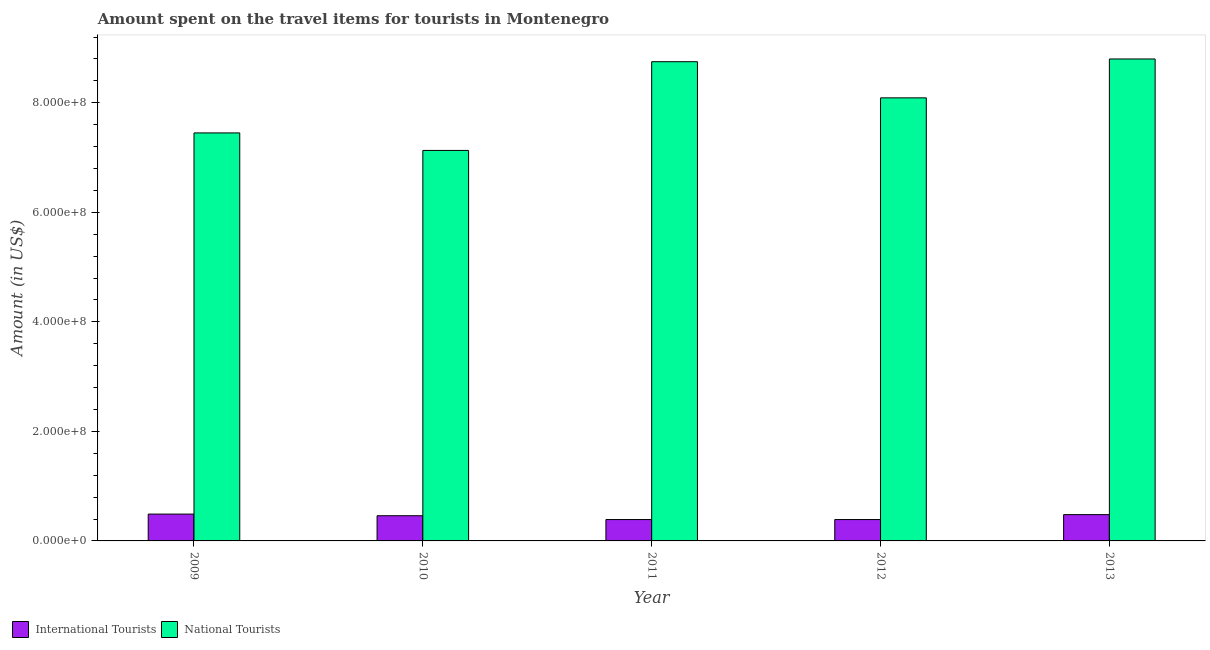How many different coloured bars are there?
Your answer should be very brief. 2. How many groups of bars are there?
Give a very brief answer. 5. How many bars are there on the 5th tick from the right?
Keep it short and to the point. 2. In how many cases, is the number of bars for a given year not equal to the number of legend labels?
Ensure brevity in your answer.  0. What is the amount spent on travel items of national tourists in 2009?
Give a very brief answer. 7.45e+08. Across all years, what is the maximum amount spent on travel items of international tourists?
Provide a succinct answer. 4.90e+07. Across all years, what is the minimum amount spent on travel items of national tourists?
Ensure brevity in your answer.  7.13e+08. In which year was the amount spent on travel items of national tourists maximum?
Give a very brief answer. 2013. In which year was the amount spent on travel items of international tourists minimum?
Your response must be concise. 2011. What is the total amount spent on travel items of national tourists in the graph?
Your answer should be compact. 4.02e+09. What is the difference between the amount spent on travel items of international tourists in 2011 and that in 2013?
Offer a terse response. -9.00e+06. What is the difference between the amount spent on travel items of national tourists in 2013 and the amount spent on travel items of international tourists in 2012?
Offer a very short reply. 7.10e+07. What is the average amount spent on travel items of international tourists per year?
Offer a very short reply. 4.42e+07. In the year 2013, what is the difference between the amount spent on travel items of international tourists and amount spent on travel items of national tourists?
Your answer should be compact. 0. What is the ratio of the amount spent on travel items of national tourists in 2009 to that in 2011?
Your answer should be very brief. 0.85. What is the difference between the highest and the second highest amount spent on travel items of national tourists?
Give a very brief answer. 5.00e+06. What is the difference between the highest and the lowest amount spent on travel items of national tourists?
Ensure brevity in your answer.  1.67e+08. In how many years, is the amount spent on travel items of international tourists greater than the average amount spent on travel items of international tourists taken over all years?
Your answer should be very brief. 3. Is the sum of the amount spent on travel items of national tourists in 2011 and 2012 greater than the maximum amount spent on travel items of international tourists across all years?
Your answer should be very brief. Yes. What does the 2nd bar from the left in 2012 represents?
Make the answer very short. National Tourists. What does the 2nd bar from the right in 2009 represents?
Ensure brevity in your answer.  International Tourists. How many bars are there?
Offer a terse response. 10. Are the values on the major ticks of Y-axis written in scientific E-notation?
Offer a very short reply. Yes. How many legend labels are there?
Provide a short and direct response. 2. How are the legend labels stacked?
Provide a succinct answer. Horizontal. What is the title of the graph?
Provide a succinct answer. Amount spent on the travel items for tourists in Montenegro. Does "RDB nonconcessional" appear as one of the legend labels in the graph?
Keep it short and to the point. No. What is the label or title of the Y-axis?
Your response must be concise. Amount (in US$). What is the Amount (in US$) in International Tourists in 2009?
Offer a very short reply. 4.90e+07. What is the Amount (in US$) in National Tourists in 2009?
Keep it short and to the point. 7.45e+08. What is the Amount (in US$) of International Tourists in 2010?
Offer a very short reply. 4.60e+07. What is the Amount (in US$) of National Tourists in 2010?
Keep it short and to the point. 7.13e+08. What is the Amount (in US$) in International Tourists in 2011?
Your response must be concise. 3.90e+07. What is the Amount (in US$) of National Tourists in 2011?
Provide a short and direct response. 8.75e+08. What is the Amount (in US$) in International Tourists in 2012?
Keep it short and to the point. 3.90e+07. What is the Amount (in US$) of National Tourists in 2012?
Your answer should be very brief. 8.09e+08. What is the Amount (in US$) of International Tourists in 2013?
Make the answer very short. 4.80e+07. What is the Amount (in US$) of National Tourists in 2013?
Offer a terse response. 8.80e+08. Across all years, what is the maximum Amount (in US$) in International Tourists?
Your answer should be compact. 4.90e+07. Across all years, what is the maximum Amount (in US$) in National Tourists?
Your answer should be compact. 8.80e+08. Across all years, what is the minimum Amount (in US$) in International Tourists?
Offer a terse response. 3.90e+07. Across all years, what is the minimum Amount (in US$) in National Tourists?
Make the answer very short. 7.13e+08. What is the total Amount (in US$) in International Tourists in the graph?
Offer a terse response. 2.21e+08. What is the total Amount (in US$) in National Tourists in the graph?
Make the answer very short. 4.02e+09. What is the difference between the Amount (in US$) of International Tourists in 2009 and that in 2010?
Your answer should be compact. 3.00e+06. What is the difference between the Amount (in US$) of National Tourists in 2009 and that in 2010?
Make the answer very short. 3.20e+07. What is the difference between the Amount (in US$) of National Tourists in 2009 and that in 2011?
Make the answer very short. -1.30e+08. What is the difference between the Amount (in US$) of National Tourists in 2009 and that in 2012?
Offer a terse response. -6.40e+07. What is the difference between the Amount (in US$) of International Tourists in 2009 and that in 2013?
Provide a short and direct response. 1.00e+06. What is the difference between the Amount (in US$) in National Tourists in 2009 and that in 2013?
Offer a very short reply. -1.35e+08. What is the difference between the Amount (in US$) of National Tourists in 2010 and that in 2011?
Give a very brief answer. -1.62e+08. What is the difference between the Amount (in US$) in National Tourists in 2010 and that in 2012?
Make the answer very short. -9.60e+07. What is the difference between the Amount (in US$) in National Tourists in 2010 and that in 2013?
Give a very brief answer. -1.67e+08. What is the difference between the Amount (in US$) in National Tourists in 2011 and that in 2012?
Keep it short and to the point. 6.60e+07. What is the difference between the Amount (in US$) of International Tourists in 2011 and that in 2013?
Your answer should be compact. -9.00e+06. What is the difference between the Amount (in US$) in National Tourists in 2011 and that in 2013?
Offer a terse response. -5.00e+06. What is the difference between the Amount (in US$) of International Tourists in 2012 and that in 2013?
Your answer should be very brief. -9.00e+06. What is the difference between the Amount (in US$) of National Tourists in 2012 and that in 2013?
Your answer should be compact. -7.10e+07. What is the difference between the Amount (in US$) of International Tourists in 2009 and the Amount (in US$) of National Tourists in 2010?
Give a very brief answer. -6.64e+08. What is the difference between the Amount (in US$) in International Tourists in 2009 and the Amount (in US$) in National Tourists in 2011?
Provide a succinct answer. -8.26e+08. What is the difference between the Amount (in US$) of International Tourists in 2009 and the Amount (in US$) of National Tourists in 2012?
Your answer should be compact. -7.60e+08. What is the difference between the Amount (in US$) in International Tourists in 2009 and the Amount (in US$) in National Tourists in 2013?
Give a very brief answer. -8.31e+08. What is the difference between the Amount (in US$) of International Tourists in 2010 and the Amount (in US$) of National Tourists in 2011?
Your answer should be very brief. -8.29e+08. What is the difference between the Amount (in US$) of International Tourists in 2010 and the Amount (in US$) of National Tourists in 2012?
Offer a very short reply. -7.63e+08. What is the difference between the Amount (in US$) of International Tourists in 2010 and the Amount (in US$) of National Tourists in 2013?
Ensure brevity in your answer.  -8.34e+08. What is the difference between the Amount (in US$) of International Tourists in 2011 and the Amount (in US$) of National Tourists in 2012?
Make the answer very short. -7.70e+08. What is the difference between the Amount (in US$) of International Tourists in 2011 and the Amount (in US$) of National Tourists in 2013?
Make the answer very short. -8.41e+08. What is the difference between the Amount (in US$) of International Tourists in 2012 and the Amount (in US$) of National Tourists in 2013?
Offer a terse response. -8.41e+08. What is the average Amount (in US$) in International Tourists per year?
Ensure brevity in your answer.  4.42e+07. What is the average Amount (in US$) of National Tourists per year?
Make the answer very short. 8.04e+08. In the year 2009, what is the difference between the Amount (in US$) in International Tourists and Amount (in US$) in National Tourists?
Offer a terse response. -6.96e+08. In the year 2010, what is the difference between the Amount (in US$) in International Tourists and Amount (in US$) in National Tourists?
Keep it short and to the point. -6.67e+08. In the year 2011, what is the difference between the Amount (in US$) of International Tourists and Amount (in US$) of National Tourists?
Offer a very short reply. -8.36e+08. In the year 2012, what is the difference between the Amount (in US$) of International Tourists and Amount (in US$) of National Tourists?
Your answer should be very brief. -7.70e+08. In the year 2013, what is the difference between the Amount (in US$) of International Tourists and Amount (in US$) of National Tourists?
Your response must be concise. -8.32e+08. What is the ratio of the Amount (in US$) of International Tourists in 2009 to that in 2010?
Offer a very short reply. 1.07. What is the ratio of the Amount (in US$) of National Tourists in 2009 to that in 2010?
Provide a succinct answer. 1.04. What is the ratio of the Amount (in US$) of International Tourists in 2009 to that in 2011?
Give a very brief answer. 1.26. What is the ratio of the Amount (in US$) in National Tourists in 2009 to that in 2011?
Give a very brief answer. 0.85. What is the ratio of the Amount (in US$) of International Tourists in 2009 to that in 2012?
Your answer should be very brief. 1.26. What is the ratio of the Amount (in US$) in National Tourists in 2009 to that in 2012?
Keep it short and to the point. 0.92. What is the ratio of the Amount (in US$) in International Tourists in 2009 to that in 2013?
Keep it short and to the point. 1.02. What is the ratio of the Amount (in US$) in National Tourists in 2009 to that in 2013?
Your answer should be compact. 0.85. What is the ratio of the Amount (in US$) in International Tourists in 2010 to that in 2011?
Ensure brevity in your answer.  1.18. What is the ratio of the Amount (in US$) in National Tourists in 2010 to that in 2011?
Your response must be concise. 0.81. What is the ratio of the Amount (in US$) of International Tourists in 2010 to that in 2012?
Provide a short and direct response. 1.18. What is the ratio of the Amount (in US$) in National Tourists in 2010 to that in 2012?
Your answer should be very brief. 0.88. What is the ratio of the Amount (in US$) in International Tourists in 2010 to that in 2013?
Your answer should be very brief. 0.96. What is the ratio of the Amount (in US$) in National Tourists in 2010 to that in 2013?
Make the answer very short. 0.81. What is the ratio of the Amount (in US$) in International Tourists in 2011 to that in 2012?
Your answer should be very brief. 1. What is the ratio of the Amount (in US$) of National Tourists in 2011 to that in 2012?
Ensure brevity in your answer.  1.08. What is the ratio of the Amount (in US$) in International Tourists in 2011 to that in 2013?
Keep it short and to the point. 0.81. What is the ratio of the Amount (in US$) of International Tourists in 2012 to that in 2013?
Offer a terse response. 0.81. What is the ratio of the Amount (in US$) of National Tourists in 2012 to that in 2013?
Your answer should be compact. 0.92. What is the difference between the highest and the lowest Amount (in US$) of National Tourists?
Provide a short and direct response. 1.67e+08. 